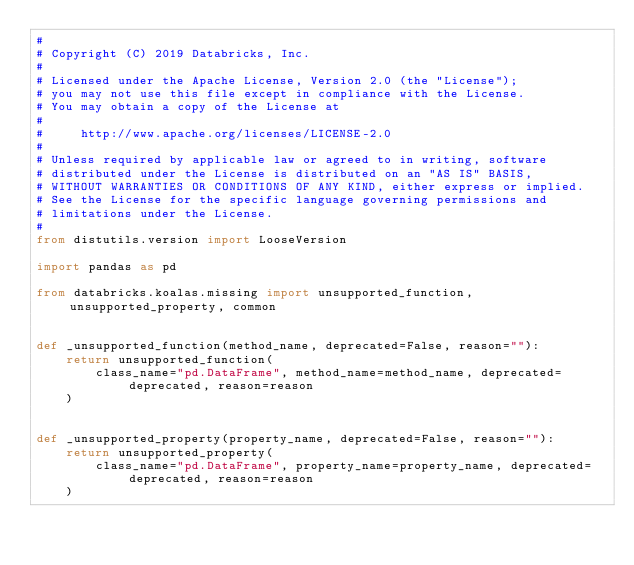<code> <loc_0><loc_0><loc_500><loc_500><_Python_>#
# Copyright (C) 2019 Databricks, Inc.
#
# Licensed under the Apache License, Version 2.0 (the "License");
# you may not use this file except in compliance with the License.
# You may obtain a copy of the License at
#
#     http://www.apache.org/licenses/LICENSE-2.0
#
# Unless required by applicable law or agreed to in writing, software
# distributed under the License is distributed on an "AS IS" BASIS,
# WITHOUT WARRANTIES OR CONDITIONS OF ANY KIND, either express or implied.
# See the License for the specific language governing permissions and
# limitations under the License.
#
from distutils.version import LooseVersion

import pandas as pd

from databricks.koalas.missing import unsupported_function, unsupported_property, common


def _unsupported_function(method_name, deprecated=False, reason=""):
    return unsupported_function(
        class_name="pd.DataFrame", method_name=method_name, deprecated=deprecated, reason=reason
    )


def _unsupported_property(property_name, deprecated=False, reason=""):
    return unsupported_property(
        class_name="pd.DataFrame", property_name=property_name, deprecated=deprecated, reason=reason
    )

</code> 